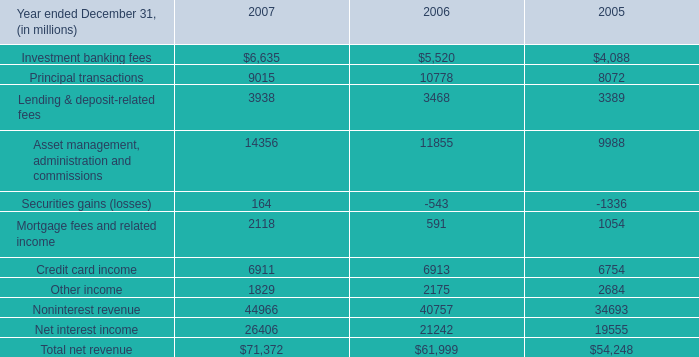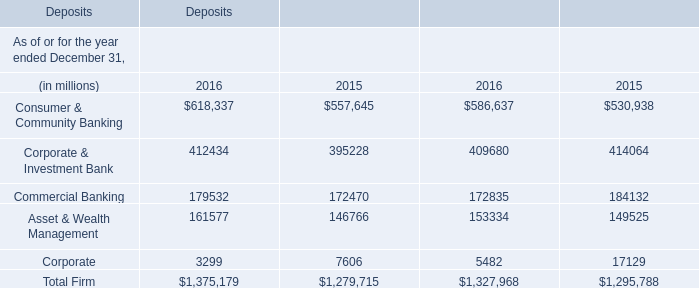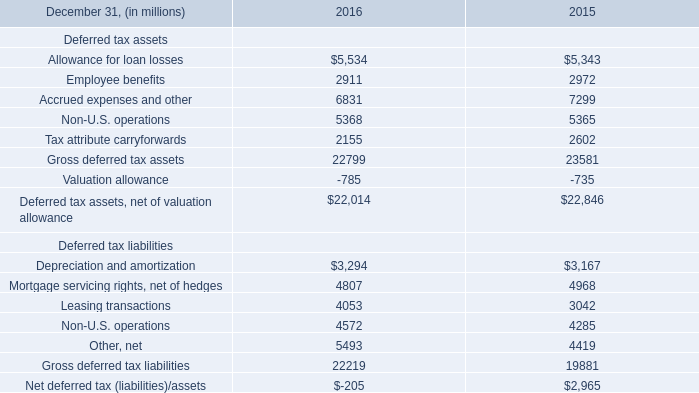what was the percentage change in investment banking fees from 2006 to 2007? 
Computations: ((6635 - 5520) / 5520)
Answer: 0.20199. 